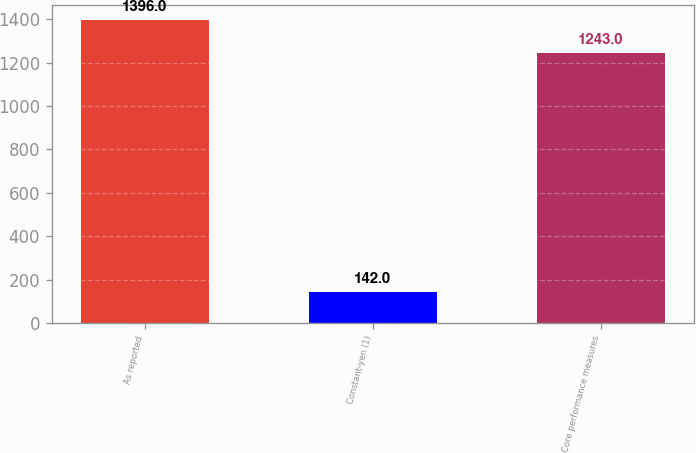<chart> <loc_0><loc_0><loc_500><loc_500><bar_chart><fcel>As reported<fcel>Constant-yen (1)<fcel>Core performance measures<nl><fcel>1396<fcel>142<fcel>1243<nl></chart> 